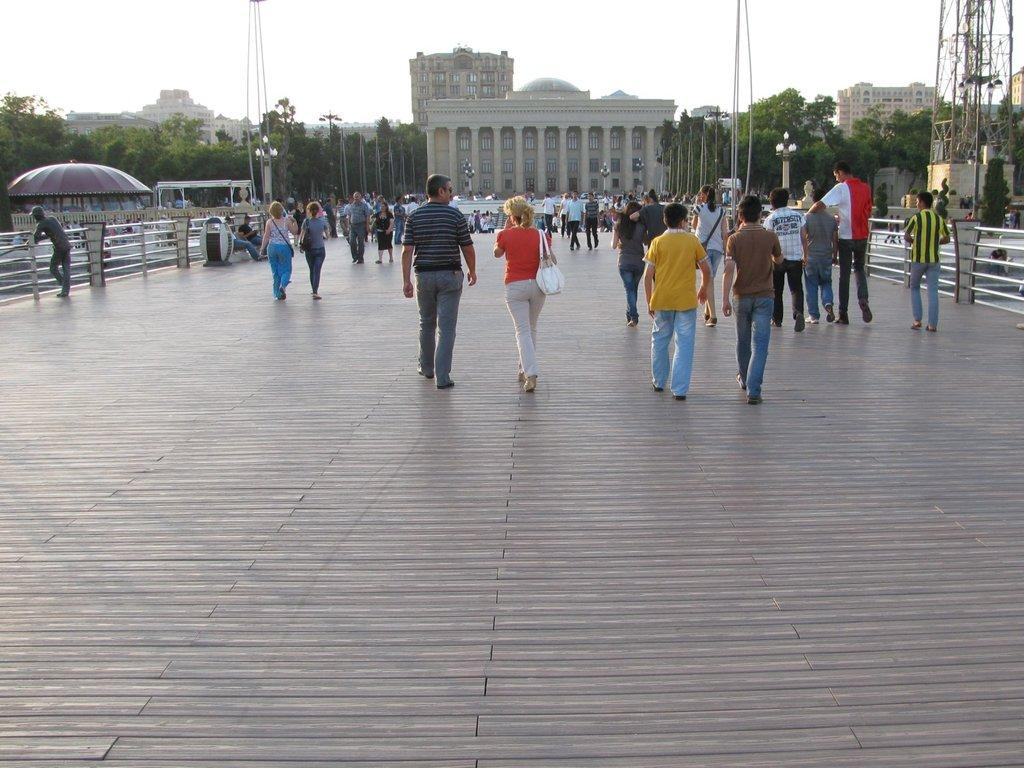What are the people in the image doing? There are persons standing, walking, and sitting in the image. What can be seen in the background of the image? There are trees and buildings in the background of the image. What objects are present in the image? There are poles and railings in the image. What is the condition of the sky in the image? The sky is cloudy in the image. Can you tell me how many pigs are visible in the image? There are no pigs present in the image. What type of knee is shown on the person walking in the image? There is no specific knee visible in the image; it is a general view of people walking. 